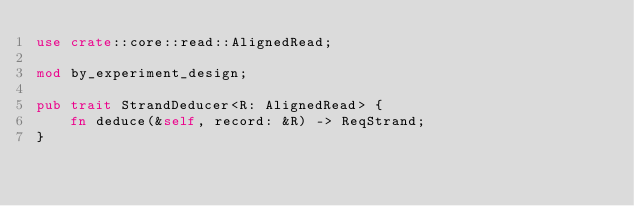<code> <loc_0><loc_0><loc_500><loc_500><_Rust_>use crate::core::read::AlignedRead;

mod by_experiment_design;

pub trait StrandDeducer<R: AlignedRead> {
    fn deduce(&self, record: &R) -> ReqStrand;
}
</code> 